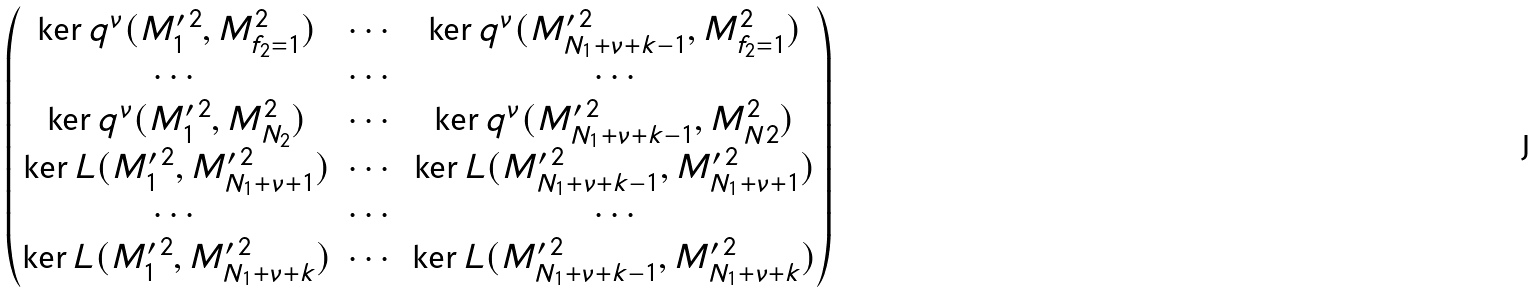<formula> <loc_0><loc_0><loc_500><loc_500>\begin{pmatrix} \ker q ^ { \nu } ( M _ { 1 } ^ { \prime \, 2 } , M _ { f _ { 2 } = 1 } ^ { 2 } ) & \cdots & \ker q ^ { \nu } ( M _ { N _ { 1 } + \nu + k - 1 } ^ { \prime \, 2 } , M _ { f _ { 2 } = 1 } ^ { 2 } ) \\ \cdots & \cdots & \cdots \\ \ker q ^ { \nu } ( M _ { 1 } ^ { \prime \, 2 } , M _ { N _ { 2 } } ^ { 2 } ) & \cdots & \ker q ^ { \nu } ( M _ { N _ { 1 } + \nu + k - 1 } ^ { \prime \, 2 } , M _ { N 2 } ^ { 2 } ) \\ \ker L ( M _ { 1 } ^ { \prime \, 2 } , M _ { N _ { 1 } + \nu + 1 } ^ { \prime \, 2 } ) & \cdots & \ker L ( M _ { N _ { 1 } + \nu + k - 1 } ^ { \prime \, 2 } , M _ { N _ { 1 } + \nu + 1 } ^ { \prime \, 2 } ) \\ \cdots & \cdots & \cdots \\ \ker L ( M _ { 1 } ^ { \prime \, 2 } , M _ { N _ { 1 } + \nu + k } ^ { \prime \, 2 } ) & \cdots & \ker L ( M _ { N _ { 1 } + \nu + k - 1 } ^ { \prime \, 2 } , M _ { N _ { 1 } + \nu + k } ^ { \prime \, 2 } ) \end{pmatrix}</formula> 